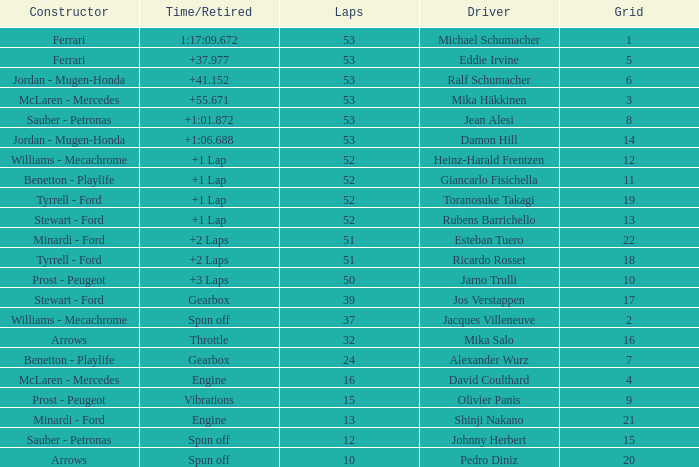What is the high lap total for pedro diniz? 10.0. Would you be able to parse every entry in this table? {'header': ['Constructor', 'Time/Retired', 'Laps', 'Driver', 'Grid'], 'rows': [['Ferrari', '1:17:09.672', '53', 'Michael Schumacher', '1'], ['Ferrari', '+37.977', '53', 'Eddie Irvine', '5'], ['Jordan - Mugen-Honda', '+41.152', '53', 'Ralf Schumacher', '6'], ['McLaren - Mercedes', '+55.671', '53', 'Mika Häkkinen', '3'], ['Sauber - Petronas', '+1:01.872', '53', 'Jean Alesi', '8'], ['Jordan - Mugen-Honda', '+1:06.688', '53', 'Damon Hill', '14'], ['Williams - Mecachrome', '+1 Lap', '52', 'Heinz-Harald Frentzen', '12'], ['Benetton - Playlife', '+1 Lap', '52', 'Giancarlo Fisichella', '11'], ['Tyrrell - Ford', '+1 Lap', '52', 'Toranosuke Takagi', '19'], ['Stewart - Ford', '+1 Lap', '52', 'Rubens Barrichello', '13'], ['Minardi - Ford', '+2 Laps', '51', 'Esteban Tuero', '22'], ['Tyrrell - Ford', '+2 Laps', '51', 'Ricardo Rosset', '18'], ['Prost - Peugeot', '+3 Laps', '50', 'Jarno Trulli', '10'], ['Stewart - Ford', 'Gearbox', '39', 'Jos Verstappen', '17'], ['Williams - Mecachrome', 'Spun off', '37', 'Jacques Villeneuve', '2'], ['Arrows', 'Throttle', '32', 'Mika Salo', '16'], ['Benetton - Playlife', 'Gearbox', '24', 'Alexander Wurz', '7'], ['McLaren - Mercedes', 'Engine', '16', 'David Coulthard', '4'], ['Prost - Peugeot', 'Vibrations', '15', 'Olivier Panis', '9'], ['Minardi - Ford', 'Engine', '13', 'Shinji Nakano', '21'], ['Sauber - Petronas', 'Spun off', '12', 'Johnny Herbert', '15'], ['Arrows', 'Spun off', '10', 'Pedro Diniz', '20']]} 